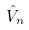<formula> <loc_0><loc_0><loc_500><loc_500>\hat { V } _ { n }</formula> 